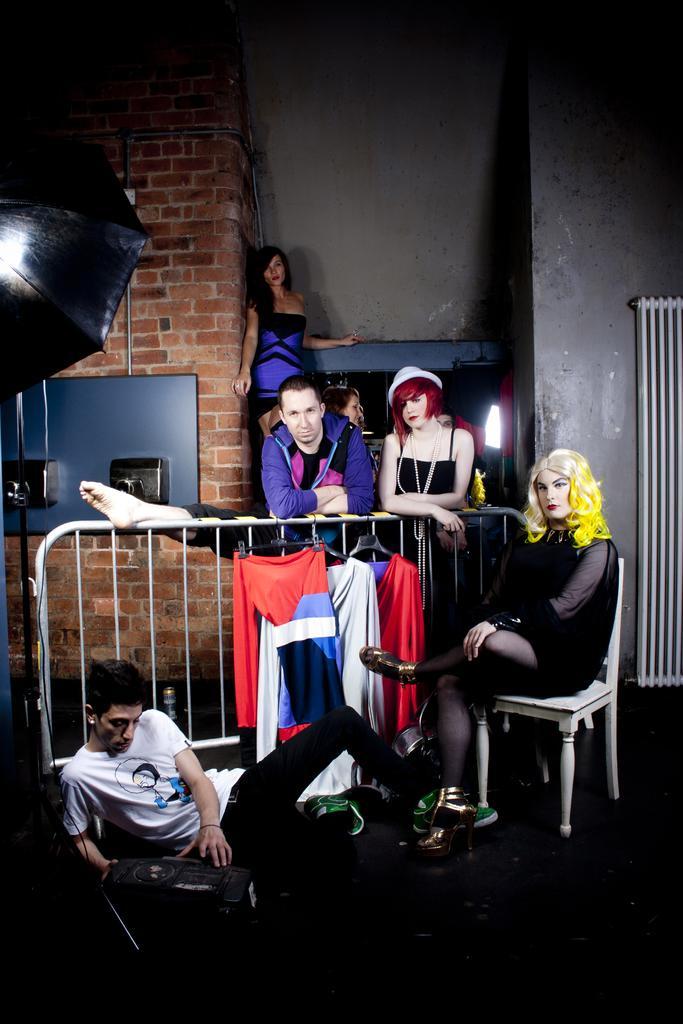Can you describe this image briefly? In the picture we can see a man sitting on the floor and leaning into it and he is wearing a white T-shirt and near him we can see a woman sitting on a chair with a black dress and behind them, we can see a railing and some clothes hung with it and behind the railing we can see a man and a woman standing and behind them also we can see a woman standing near the wall and the wall is with bricks. 